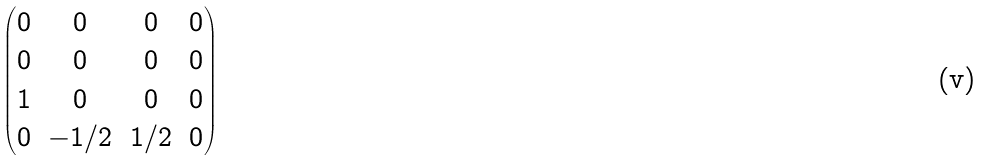Convert formula to latex. <formula><loc_0><loc_0><loc_500><loc_500>\begin{pmatrix} 0 & 0 & 0 & 0 \\ 0 & 0 & 0 & 0 \\ 1 & 0 & 0 & 0 \\ 0 & - 1 / 2 & 1 / 2 & 0 \\ \end{pmatrix}</formula> 